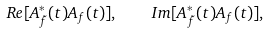Convert formula to latex. <formula><loc_0><loc_0><loc_500><loc_500>R e [ A _ { \tilde { f } } ^ { \ast } ( t ) A _ { f } ( t ) ] , \quad I m [ A _ { \tilde { f } } ^ { \ast } ( t ) A _ { f } ( t ) ] ,</formula> 